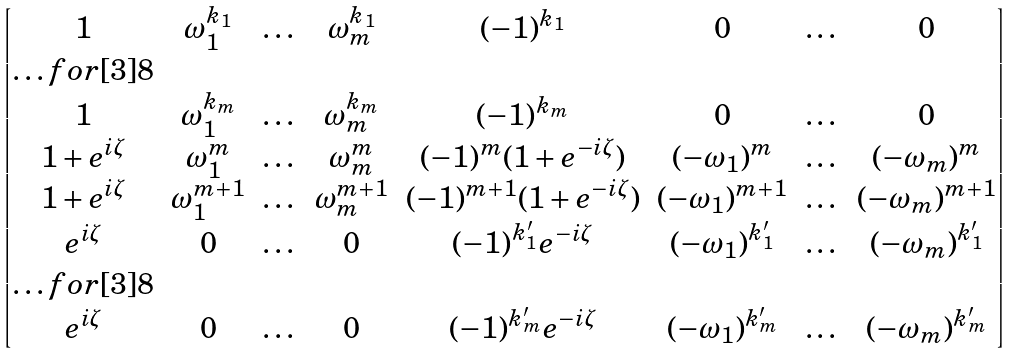Convert formula to latex. <formula><loc_0><loc_0><loc_500><loc_500>\begin{bmatrix} 1 & \omega _ { 1 } ^ { k _ { 1 } } & \dots & \omega _ { m } ^ { k _ { 1 } } & ( - 1 ) ^ { k _ { 1 } } & 0 & \dots & 0 \\ \hdots f o r [ 3 ] { 8 } \\ 1 & \omega _ { 1 } ^ { k _ { m } } & \dots & \omega _ { m } ^ { k _ { m } } & ( - 1 ) ^ { k _ { m } } & 0 & \dots & 0 \\ 1 + e ^ { i \zeta } & \omega _ { 1 } ^ { m } & \dots & \omega _ { m } ^ { m } & ( - 1 ) ^ { m } ( 1 + e ^ { - i \zeta } ) & ( - \omega _ { 1 } ) ^ { m } & \dots & ( - \omega _ { m } ) ^ { m } \\ 1 + e ^ { i \zeta } & \omega _ { 1 } ^ { m + 1 } & \dots & \omega _ { m } ^ { m + 1 } & ( - 1 ) ^ { m + 1 } ( 1 + e ^ { - i \zeta } ) & ( - \omega _ { 1 } ) ^ { m + 1 } & \dots & ( - \omega _ { m } ) ^ { m + 1 } \\ e ^ { i \zeta } & 0 & \dots & 0 & ( - 1 ) ^ { k ^ { \prime } _ { 1 } } e ^ { - i \zeta } & ( - \omega _ { 1 } ) ^ { k ^ { \prime } _ { 1 } } & \dots & ( - \omega _ { m } ) ^ { k ^ { \prime } _ { 1 } } \\ \hdots f o r [ 3 ] { 8 } \\ e ^ { i \zeta } & 0 & \dots & 0 & ( - 1 ) ^ { k ^ { \prime } _ { m } } e ^ { - i \zeta } & ( - \omega _ { 1 } ) ^ { k ^ { \prime } _ { m } } & \dots & ( - \omega _ { m } ) ^ { k ^ { \prime } _ { m } } \\ \end{bmatrix}</formula> 